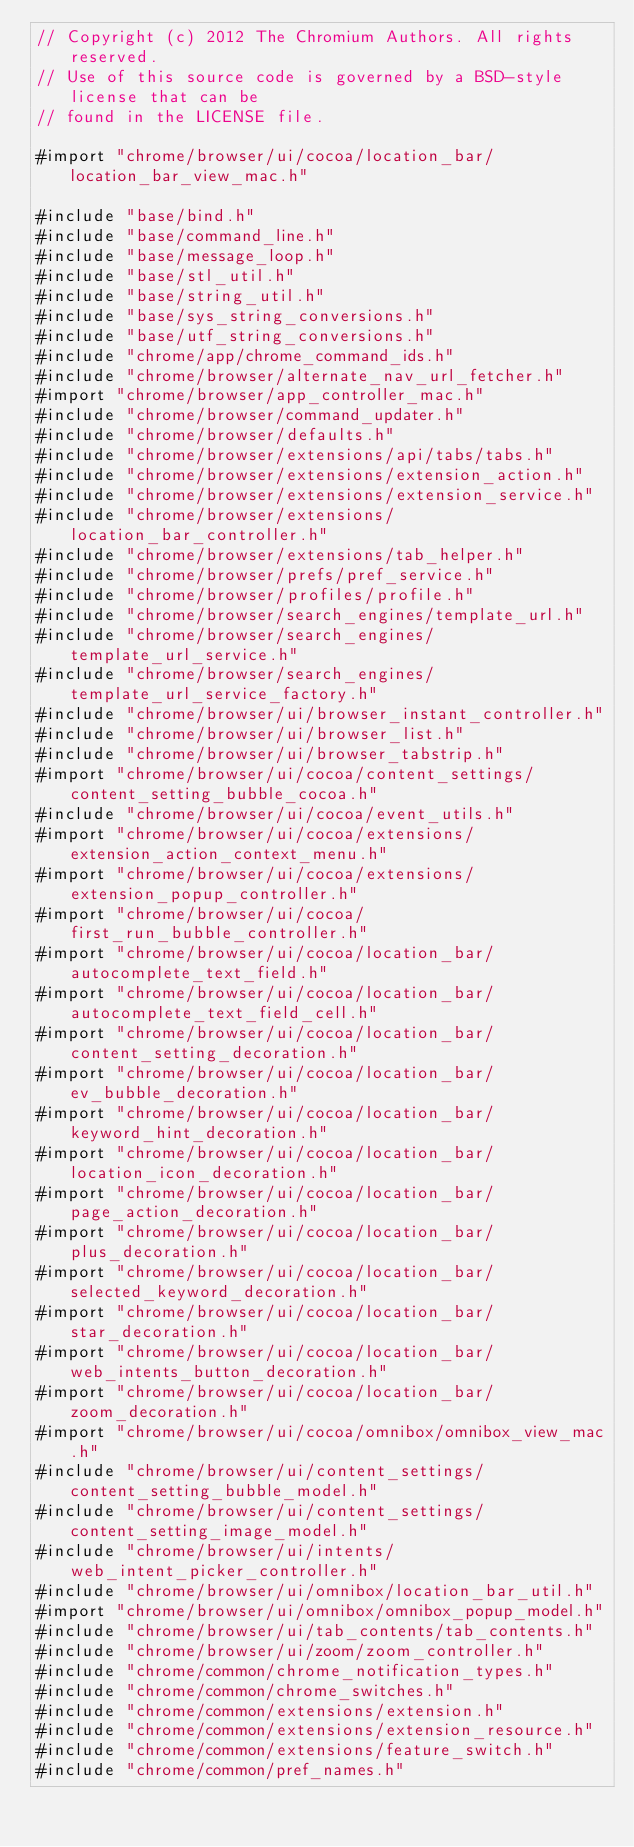Convert code to text. <code><loc_0><loc_0><loc_500><loc_500><_ObjectiveC_>// Copyright (c) 2012 The Chromium Authors. All rights reserved.
// Use of this source code is governed by a BSD-style license that can be
// found in the LICENSE file.

#import "chrome/browser/ui/cocoa/location_bar/location_bar_view_mac.h"

#include "base/bind.h"
#include "base/command_line.h"
#include "base/message_loop.h"
#include "base/stl_util.h"
#include "base/string_util.h"
#include "base/sys_string_conversions.h"
#include "base/utf_string_conversions.h"
#include "chrome/app/chrome_command_ids.h"
#include "chrome/browser/alternate_nav_url_fetcher.h"
#import "chrome/browser/app_controller_mac.h"
#include "chrome/browser/command_updater.h"
#include "chrome/browser/defaults.h"
#include "chrome/browser/extensions/api/tabs/tabs.h"
#include "chrome/browser/extensions/extension_action.h"
#include "chrome/browser/extensions/extension_service.h"
#include "chrome/browser/extensions/location_bar_controller.h"
#include "chrome/browser/extensions/tab_helper.h"
#include "chrome/browser/prefs/pref_service.h"
#include "chrome/browser/profiles/profile.h"
#include "chrome/browser/search_engines/template_url.h"
#include "chrome/browser/search_engines/template_url_service.h"
#include "chrome/browser/search_engines/template_url_service_factory.h"
#include "chrome/browser/ui/browser_instant_controller.h"
#include "chrome/browser/ui/browser_list.h"
#include "chrome/browser/ui/browser_tabstrip.h"
#import "chrome/browser/ui/cocoa/content_settings/content_setting_bubble_cocoa.h"
#include "chrome/browser/ui/cocoa/event_utils.h"
#import "chrome/browser/ui/cocoa/extensions/extension_action_context_menu.h"
#import "chrome/browser/ui/cocoa/extensions/extension_popup_controller.h"
#import "chrome/browser/ui/cocoa/first_run_bubble_controller.h"
#import "chrome/browser/ui/cocoa/location_bar/autocomplete_text_field.h"
#import "chrome/browser/ui/cocoa/location_bar/autocomplete_text_field_cell.h"
#import "chrome/browser/ui/cocoa/location_bar/content_setting_decoration.h"
#import "chrome/browser/ui/cocoa/location_bar/ev_bubble_decoration.h"
#import "chrome/browser/ui/cocoa/location_bar/keyword_hint_decoration.h"
#import "chrome/browser/ui/cocoa/location_bar/location_icon_decoration.h"
#import "chrome/browser/ui/cocoa/location_bar/page_action_decoration.h"
#import "chrome/browser/ui/cocoa/location_bar/plus_decoration.h"
#import "chrome/browser/ui/cocoa/location_bar/selected_keyword_decoration.h"
#import "chrome/browser/ui/cocoa/location_bar/star_decoration.h"
#import "chrome/browser/ui/cocoa/location_bar/web_intents_button_decoration.h"
#import "chrome/browser/ui/cocoa/location_bar/zoom_decoration.h"
#import "chrome/browser/ui/cocoa/omnibox/omnibox_view_mac.h"
#include "chrome/browser/ui/content_settings/content_setting_bubble_model.h"
#include "chrome/browser/ui/content_settings/content_setting_image_model.h"
#include "chrome/browser/ui/intents/web_intent_picker_controller.h"
#include "chrome/browser/ui/omnibox/location_bar_util.h"
#import "chrome/browser/ui/omnibox/omnibox_popup_model.h"
#include "chrome/browser/ui/tab_contents/tab_contents.h"
#include "chrome/browser/ui/zoom/zoom_controller.h"
#include "chrome/common/chrome_notification_types.h"
#include "chrome/common/chrome_switches.h"
#include "chrome/common/extensions/extension.h"
#include "chrome/common/extensions/extension_resource.h"
#include "chrome/common/extensions/feature_switch.h"
#include "chrome/common/pref_names.h"</code> 